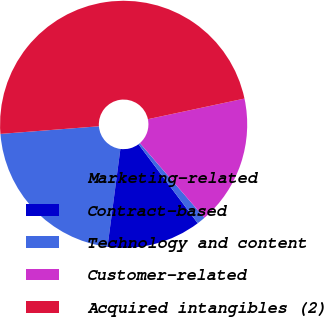<chart> <loc_0><loc_0><loc_500><loc_500><pie_chart><fcel>Marketing-related<fcel>Contract-based<fcel>Technology and content<fcel>Customer-related<fcel>Acquired intangibles (2)<nl><fcel>21.68%<fcel>12.32%<fcel>1.11%<fcel>17.0%<fcel>47.88%<nl></chart> 